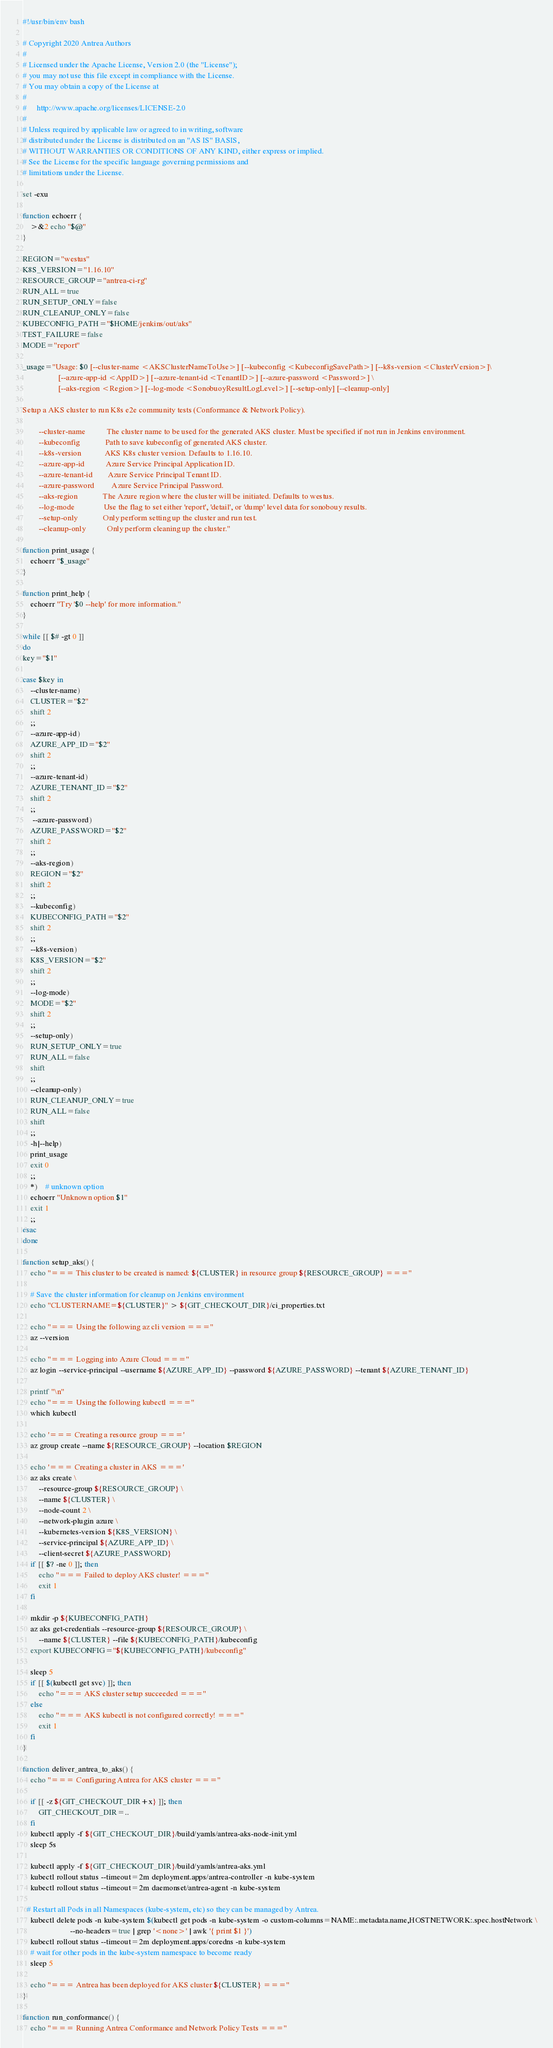Convert code to text. <code><loc_0><loc_0><loc_500><loc_500><_Bash_>#!/usr/bin/env bash

# Copyright 2020 Antrea Authors
#
# Licensed under the Apache License, Version 2.0 (the "License");
# you may not use this file except in compliance with the License.
# You may obtain a copy of the License at
#
#     http://www.apache.org/licenses/LICENSE-2.0
#
# Unless required by applicable law or agreed to in writing, software
# distributed under the License is distributed on an "AS IS" BASIS,
# WITHOUT WARRANTIES OR CONDITIONS OF ANY KIND, either express or implied.
# See the License for the specific language governing permissions and
# limitations under the License.

set -exu

function echoerr {
    >&2 echo "$@"
}

REGION="westus"
K8S_VERSION="1.16.10"
RESOURCE_GROUP="antrea-ci-rg"
RUN_ALL=true
RUN_SETUP_ONLY=false
RUN_CLEANUP_ONLY=false
KUBECONFIG_PATH="$HOME/jenkins/out/aks"
TEST_FAILURE=false
MODE="report"

_usage="Usage: $0 [--cluster-name <AKSClusterNameToUse>] [--kubeconfig <KubeconfigSavePath>] [--k8s-version <ClusterVersion>]\
                  [--azure-app-id <AppID>] [--azure-tenant-id <TenantID>] [--azure-password <Password>] \
                  [--aks-region <Region>] [--log-mode <SonobuoyResultLogLevel>] [--setup-only] [--cleanup-only]

Setup a AKS cluster to run K8s e2e community tests (Conformance & Network Policy).

        --cluster-name           The cluster name to be used for the generated AKS cluster. Must be specified if not run in Jenkins environment.
        --kubeconfig             Path to save kubeconfig of generated AKS cluster.
        --k8s-version            AKS K8s cluster version. Defaults to 1.16.10.
        --azure-app-id           Azure Service Principal Application ID.
        --azure-tenant-id        Azure Service Principal Tenant ID.
        --azure-password         Azure Service Principal Password.
        --aks-region             The Azure region where the cluster will be initiated. Defaults to westus.
        --log-mode               Use the flag to set either 'report', 'detail', or 'dump' level data for sonobouy results.
        --setup-only             Only perform setting up the cluster and run test.
        --cleanup-only           Only perform cleaning up the cluster."

function print_usage {
    echoerr "$_usage"
}

function print_help {
    echoerr "Try '$0 --help' for more information."
}

while [[ $# -gt 0 ]]
do
key="$1"

case $key in
    --cluster-name)
    CLUSTER="$2"
    shift 2
    ;;
    --azure-app-id)
    AZURE_APP_ID="$2"
    shift 2
    ;;
    --azure-tenant-id)
    AZURE_TENANT_ID="$2"
    shift 2
    ;;
     --azure-password)
    AZURE_PASSWORD="$2"
    shift 2
    ;;
    --aks-region)
    REGION="$2"
    shift 2
    ;;
    --kubeconfig)
    KUBECONFIG_PATH="$2"
    shift 2
    ;;
    --k8s-version)
    K8S_VERSION="$2"
    shift 2
    ;;
    --log-mode)
    MODE="$2"
    shift 2
    ;;
    --setup-only)
    RUN_SETUP_ONLY=true
    RUN_ALL=false
    shift
    ;;
    --cleanup-only)
    RUN_CLEANUP_ONLY=true
    RUN_ALL=false
    shift
    ;;
    -h|--help)
    print_usage
    exit 0
    ;;
    *)    # unknown option
    echoerr "Unknown option $1"
    exit 1
    ;;
esac
done

function setup_aks() {
    echo "=== This cluster to be created is named: ${CLUSTER} in resource group ${RESOURCE_GROUP} ==="

    # Save the cluster information for cleanup on Jenkins environment
    echo "CLUSTERNAME=${CLUSTER}" > ${GIT_CHECKOUT_DIR}/ci_properties.txt

    echo "=== Using the following az cli version ==="
    az --version

    echo "=== Logging into Azure Cloud ==="
    az login --service-principal --username ${AZURE_APP_ID} --password ${AZURE_PASSWORD} --tenant ${AZURE_TENANT_ID}

    printf "\n"
    echo "=== Using the following kubectl ==="
    which kubectl

    echo '=== Creating a resource group ==='
    az group create --name ${RESOURCE_GROUP} --location $REGION

    echo '=== Creating a cluster in AKS ==='
    az aks create \
        --resource-group ${RESOURCE_GROUP} \
        --name ${CLUSTER} \
        --node-count 2 \
        --network-plugin azure \
        --kubernetes-version ${K8S_VERSION} \
        --service-principal ${AZURE_APP_ID} \
        --client-secret ${AZURE_PASSWORD}
    if [[ $? -ne 0 ]]; then
        echo "=== Failed to deploy AKS cluster! ==="
        exit 1
    fi

    mkdir -p ${KUBECONFIG_PATH}
    az aks get-credentials --resource-group ${RESOURCE_GROUP} \
        --name ${CLUSTER} --file ${KUBECONFIG_PATH}/kubeconfig
    export KUBECONFIG="${KUBECONFIG_PATH}/kubeconfig"

    sleep 5
    if [[ $(kubectl get svc) ]]; then
        echo "=== AKS cluster setup succeeded ==="
    else
        echo "=== AKS kubectl is not configured correctly! ==="
        exit 1
    fi
}

function deliver_antrea_to_aks() {
    echo "=== Configuring Antrea for AKS cluster ==="

    if [[ -z ${GIT_CHECKOUT_DIR+x} ]]; then
        GIT_CHECKOUT_DIR=..
    fi
    kubectl apply -f ${GIT_CHECKOUT_DIR}/build/yamls/antrea-aks-node-init.yml
    sleep 5s

    kubectl apply -f ${GIT_CHECKOUT_DIR}/build/yamls/antrea-aks.yml
    kubectl rollout status --timeout=2m deployment.apps/antrea-controller -n kube-system
    kubectl rollout status --timeout=2m daemonset/antrea-agent -n kube-system

  # Restart all Pods in all Namespaces (kube-system, etc) so they can be managed by Antrea.
    kubectl delete pods -n kube-system $(kubectl get pods -n kube-system -o custom-columns=NAME:.metadata.name,HOSTNETWORK:.spec.hostNetwork \
                        --no-headers=true | grep '<none>' | awk '{ print $1 }')
    kubectl rollout status --timeout=2m deployment.apps/coredns -n kube-system
    # wait for other pods in the kube-system namespace to become ready
    sleep 5

    echo "=== Antrea has been deployed for AKS cluster ${CLUSTER} ==="
}

function run_conformance() {
    echo "=== Running Antrea Conformance and Network Policy Tests ==="</code> 